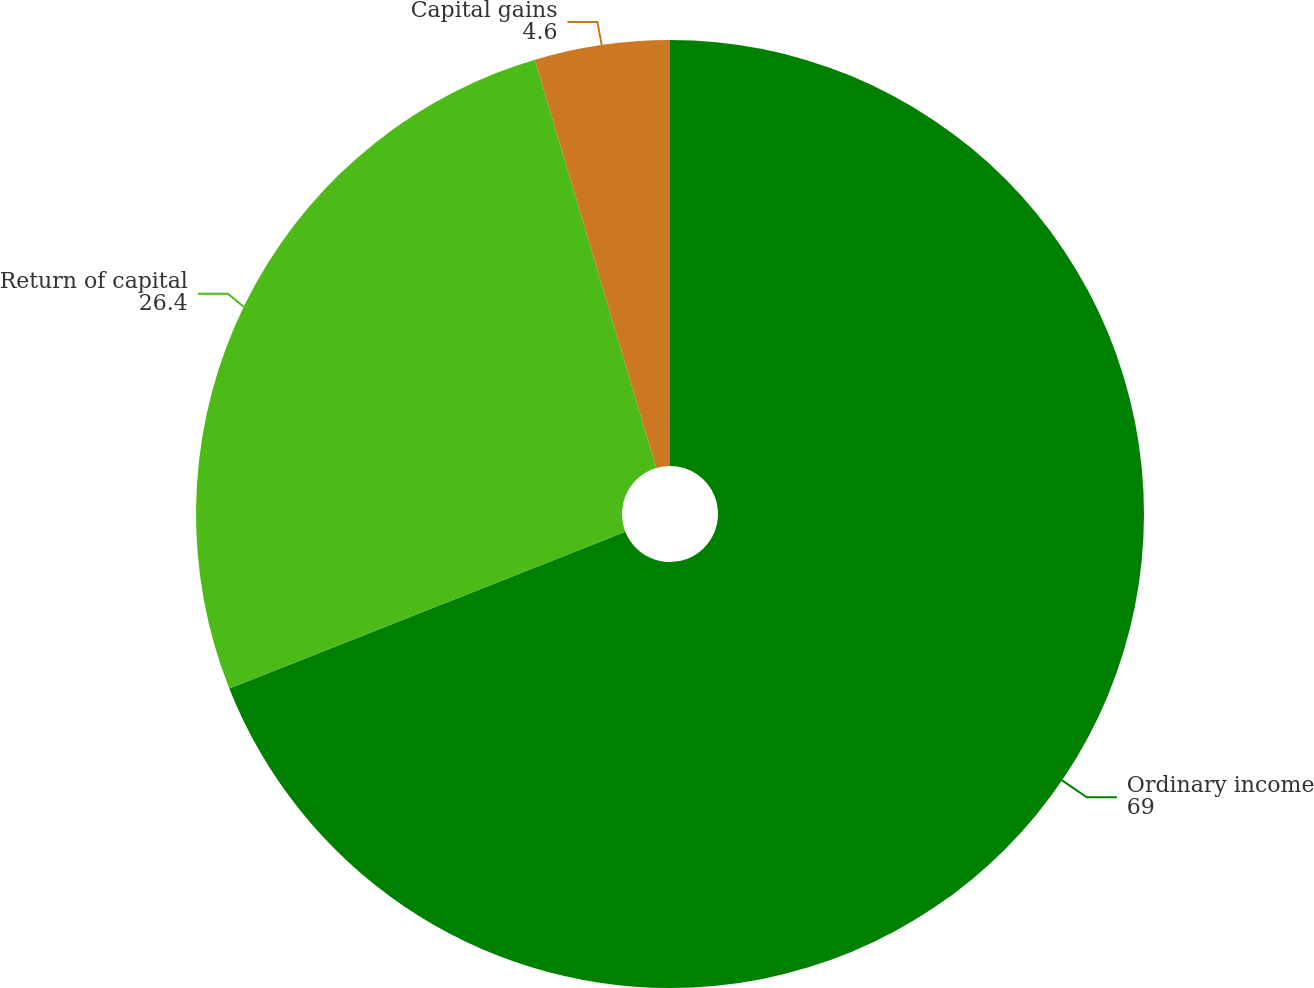<chart> <loc_0><loc_0><loc_500><loc_500><pie_chart><fcel>Ordinary income<fcel>Return of capital<fcel>Capital gains<nl><fcel>69.0%<fcel>26.4%<fcel>4.6%<nl></chart> 